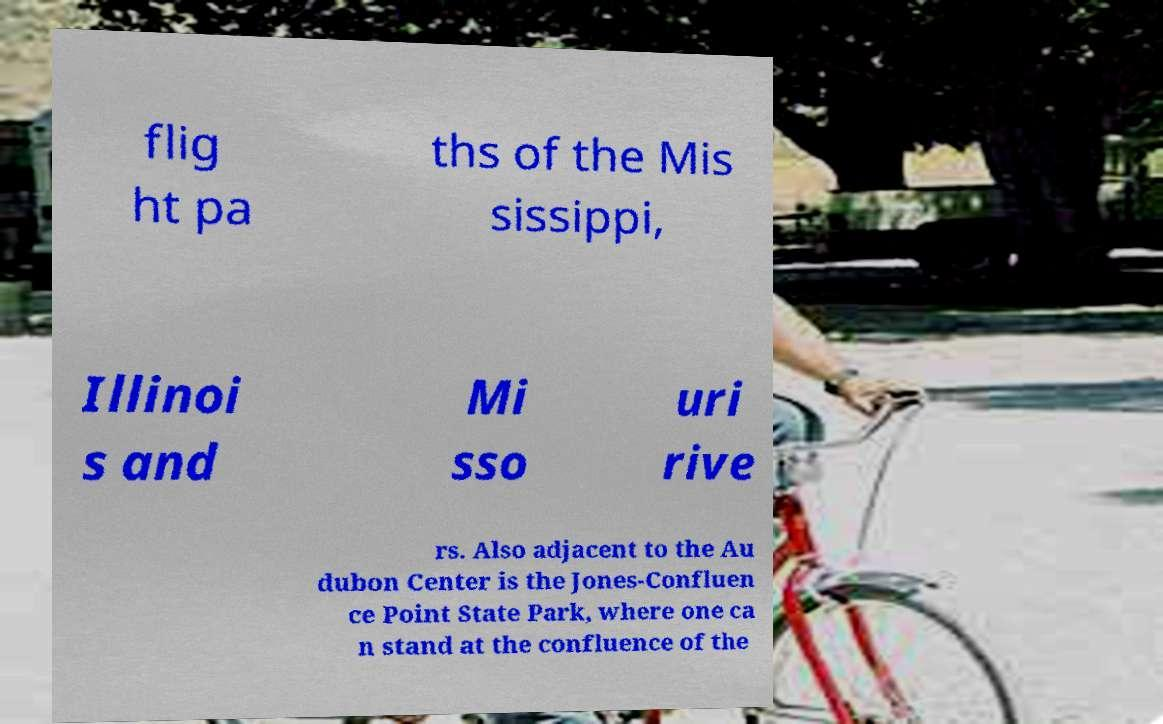Please identify and transcribe the text found in this image. flig ht pa ths of the Mis sissippi, Illinoi s and Mi sso uri rive rs. Also adjacent to the Au dubon Center is the Jones-Confluen ce Point State Park, where one ca n stand at the confluence of the 